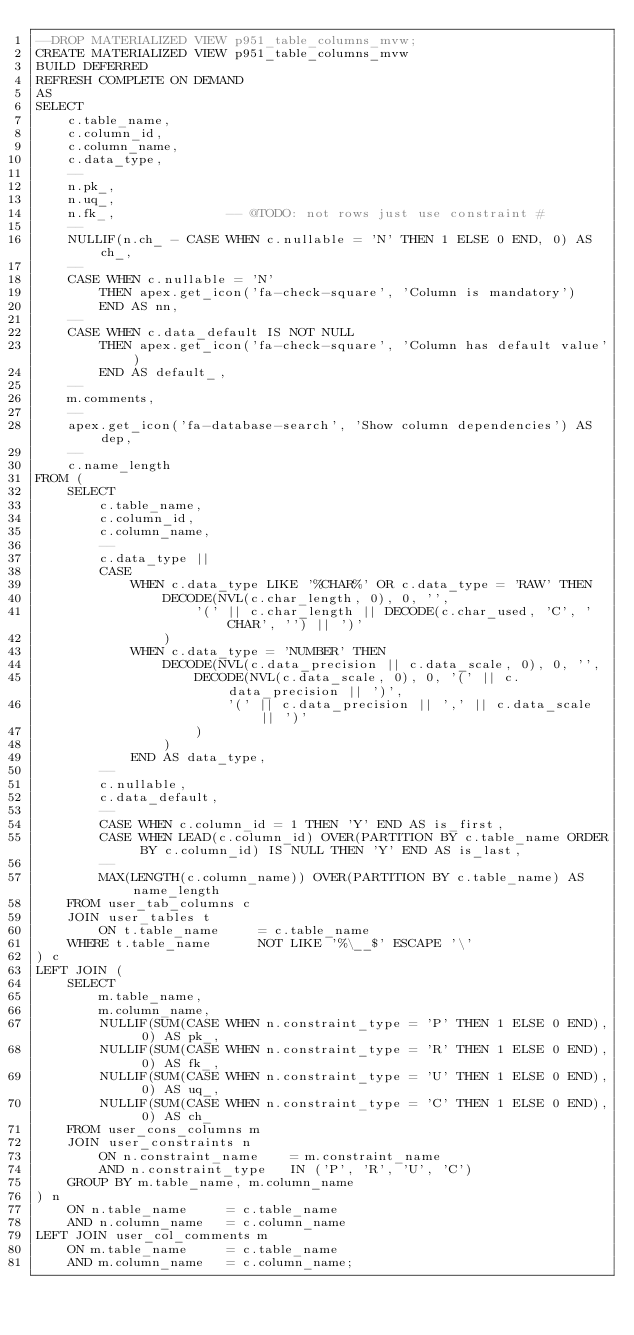<code> <loc_0><loc_0><loc_500><loc_500><_SQL_>--DROP MATERIALIZED VIEW p951_table_columns_mvw;
CREATE MATERIALIZED VIEW p951_table_columns_mvw
BUILD DEFERRED
REFRESH COMPLETE ON DEMAND
AS
SELECT
    c.table_name,
    c.column_id,
    c.column_name,
    c.data_type,
    --
    n.pk_,
    n.uq_,
    n.fk_,              -- @TODO: not rows just use constraint #
    --
    NULLIF(n.ch_ - CASE WHEN c.nullable = 'N' THEN 1 ELSE 0 END, 0) AS ch_,
    --
    CASE WHEN c.nullable = 'N'
        THEN apex.get_icon('fa-check-square', 'Column is mandatory')
        END AS nn,
    --
    CASE WHEN c.data_default IS NOT NULL
        THEN apex.get_icon('fa-check-square', 'Column has default value')
        END AS default_,
    --
    m.comments,
    --
    apex.get_icon('fa-database-search', 'Show column dependencies') AS dep,
    --
    c.name_length
FROM (
    SELECT
        c.table_name,
        c.column_id,
        c.column_name,
        --
        c.data_type ||
        CASE
            WHEN c.data_type LIKE '%CHAR%' OR c.data_type = 'RAW' THEN
                DECODE(NVL(c.char_length, 0), 0, '',
                    '(' || c.char_length || DECODE(c.char_used, 'C', ' CHAR', '') || ')'
                )
            WHEN c.data_type = 'NUMBER' THEN
                DECODE(NVL(c.data_precision || c.data_scale, 0), 0, '',
                    DECODE(NVL(c.data_scale, 0), 0, '(' || c.data_precision || ')',
                        '(' || c.data_precision || ',' || c.data_scale || ')'
                    )
                )
            END AS data_type,
        --
        c.nullable,
        c.data_default,
        --
        CASE WHEN c.column_id = 1 THEN 'Y' END AS is_first,
        CASE WHEN LEAD(c.column_id) OVER(PARTITION BY c.table_name ORDER BY c.column_id) IS NULL THEN 'Y' END AS is_last,
        --
        MAX(LENGTH(c.column_name)) OVER(PARTITION BY c.table_name) AS name_length
    FROM user_tab_columns c
    JOIN user_tables t
        ON t.table_name     = c.table_name
    WHERE t.table_name      NOT LIKE '%\__$' ESCAPE '\'
) c
LEFT JOIN (
    SELECT
        m.table_name,
        m.column_name,
        NULLIF(SUM(CASE WHEN n.constraint_type = 'P' THEN 1 ELSE 0 END), 0) AS pk_,
        NULLIF(SUM(CASE WHEN n.constraint_type = 'R' THEN 1 ELSE 0 END), 0) AS fk_,
        NULLIF(SUM(CASE WHEN n.constraint_type = 'U' THEN 1 ELSE 0 END), 0) AS uq_,
        NULLIF(SUM(CASE WHEN n.constraint_type = 'C' THEN 1 ELSE 0 END), 0) AS ch_
    FROM user_cons_columns m
    JOIN user_constraints n
        ON n.constraint_name    = m.constraint_name
        AND n.constraint_type   IN ('P', 'R', 'U', 'C')
    GROUP BY m.table_name, m.column_name
) n
    ON n.table_name     = c.table_name
    AND n.column_name   = c.column_name
LEFT JOIN user_col_comments m
    ON m.table_name     = c.table_name
    AND m.column_name   = c.column_name;

</code> 